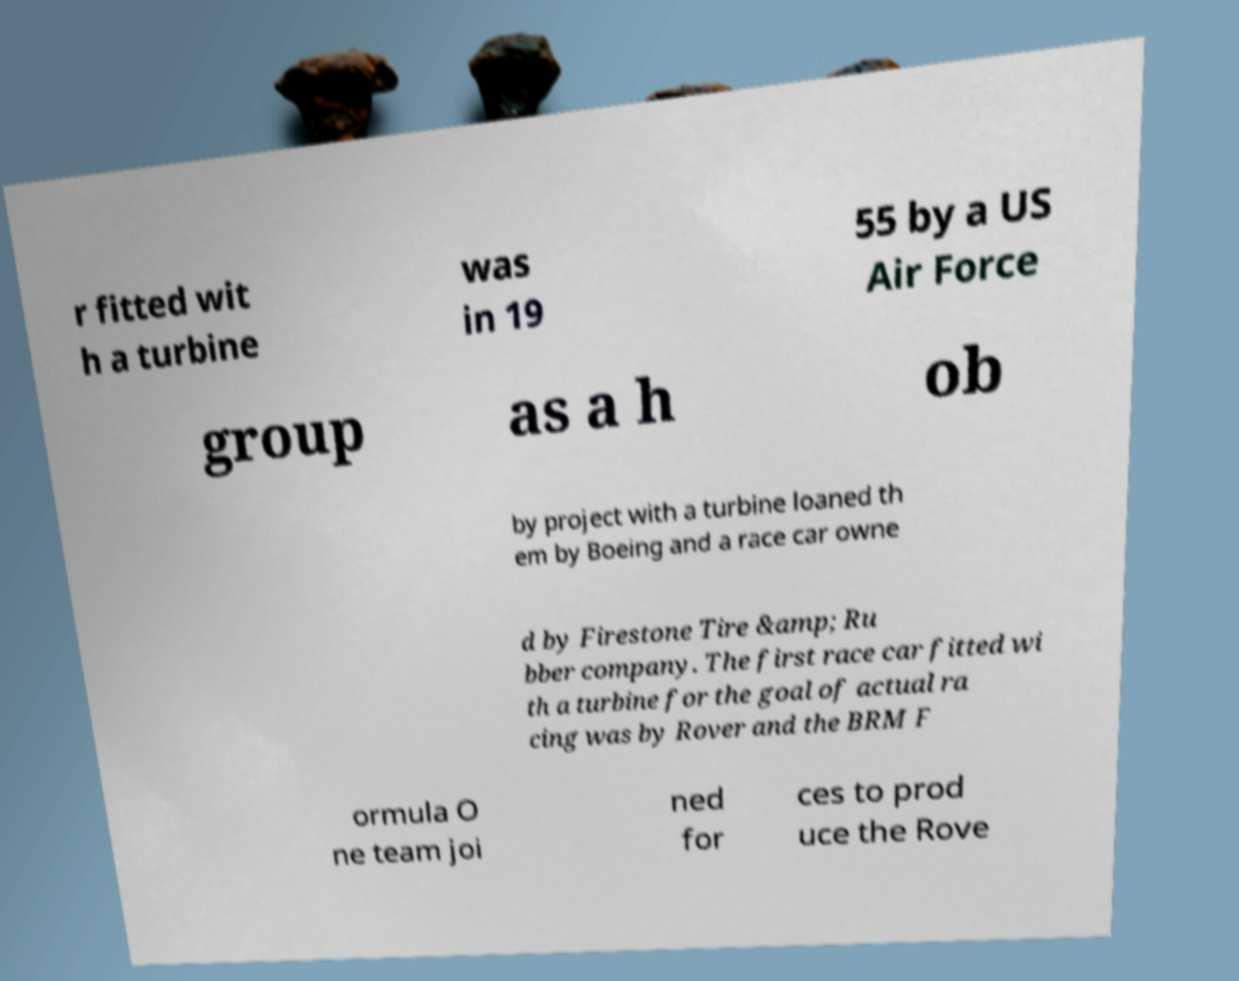Could you assist in decoding the text presented in this image and type it out clearly? r fitted wit h a turbine was in 19 55 by a US Air Force group as a h ob by project with a turbine loaned th em by Boeing and a race car owne d by Firestone Tire &amp; Ru bber company. The first race car fitted wi th a turbine for the goal of actual ra cing was by Rover and the BRM F ormula O ne team joi ned for ces to prod uce the Rove 